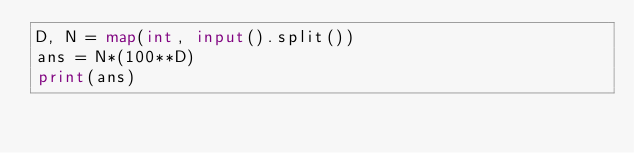<code> <loc_0><loc_0><loc_500><loc_500><_Python_>D, N = map(int, input().split())
ans = N*(100**D)
print(ans)</code> 